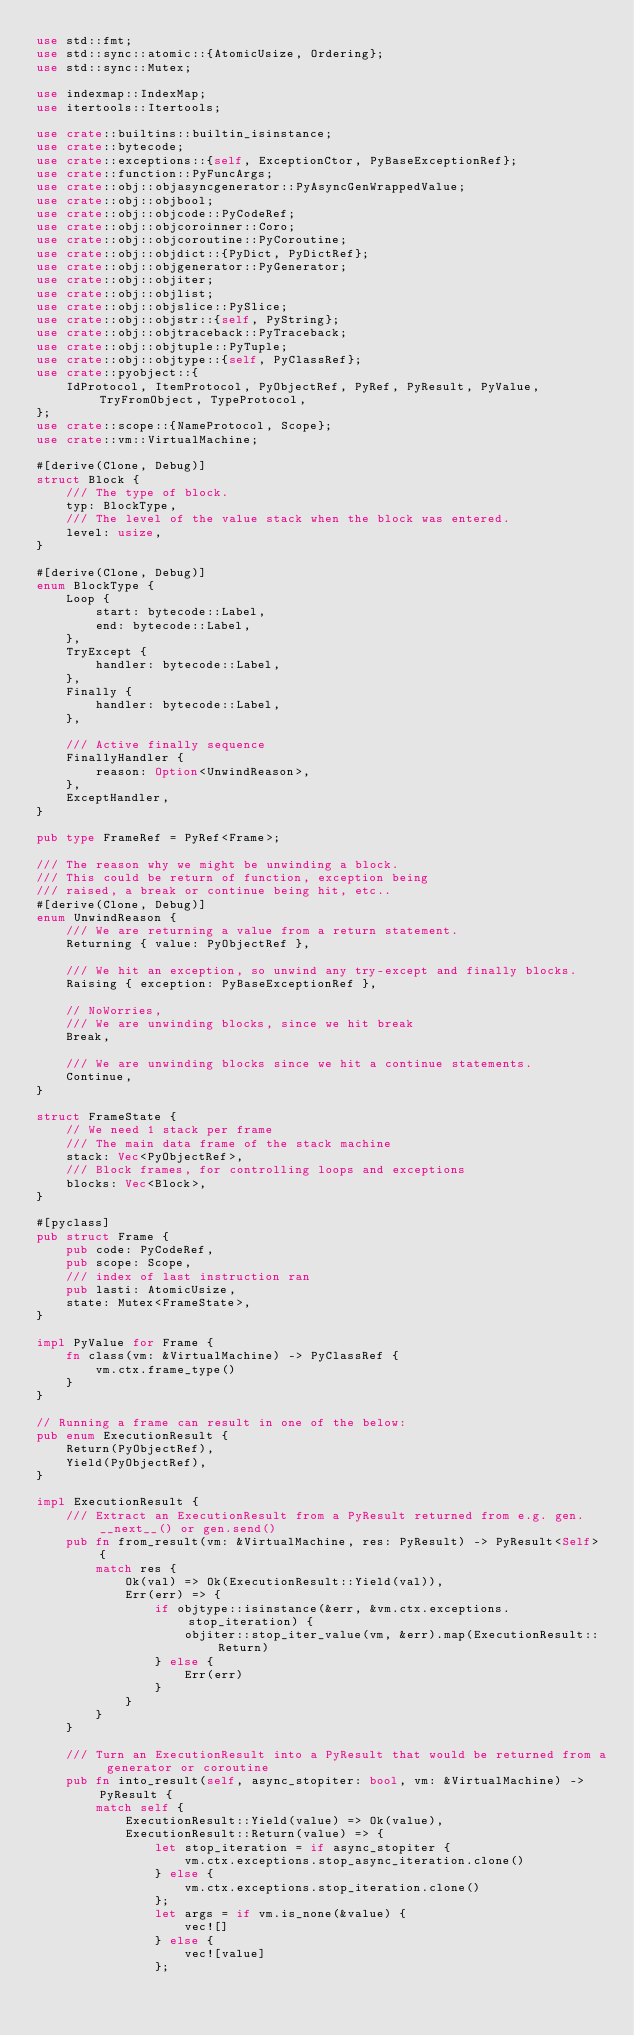<code> <loc_0><loc_0><loc_500><loc_500><_Rust_>use std::fmt;
use std::sync::atomic::{AtomicUsize, Ordering};
use std::sync::Mutex;

use indexmap::IndexMap;
use itertools::Itertools;

use crate::builtins::builtin_isinstance;
use crate::bytecode;
use crate::exceptions::{self, ExceptionCtor, PyBaseExceptionRef};
use crate::function::PyFuncArgs;
use crate::obj::objasyncgenerator::PyAsyncGenWrappedValue;
use crate::obj::objbool;
use crate::obj::objcode::PyCodeRef;
use crate::obj::objcoroinner::Coro;
use crate::obj::objcoroutine::PyCoroutine;
use crate::obj::objdict::{PyDict, PyDictRef};
use crate::obj::objgenerator::PyGenerator;
use crate::obj::objiter;
use crate::obj::objlist;
use crate::obj::objslice::PySlice;
use crate::obj::objstr::{self, PyString};
use crate::obj::objtraceback::PyTraceback;
use crate::obj::objtuple::PyTuple;
use crate::obj::objtype::{self, PyClassRef};
use crate::pyobject::{
    IdProtocol, ItemProtocol, PyObjectRef, PyRef, PyResult, PyValue, TryFromObject, TypeProtocol,
};
use crate::scope::{NameProtocol, Scope};
use crate::vm::VirtualMachine;

#[derive(Clone, Debug)]
struct Block {
    /// The type of block.
    typ: BlockType,
    /// The level of the value stack when the block was entered.
    level: usize,
}

#[derive(Clone, Debug)]
enum BlockType {
    Loop {
        start: bytecode::Label,
        end: bytecode::Label,
    },
    TryExcept {
        handler: bytecode::Label,
    },
    Finally {
        handler: bytecode::Label,
    },

    /// Active finally sequence
    FinallyHandler {
        reason: Option<UnwindReason>,
    },
    ExceptHandler,
}

pub type FrameRef = PyRef<Frame>;

/// The reason why we might be unwinding a block.
/// This could be return of function, exception being
/// raised, a break or continue being hit, etc..
#[derive(Clone, Debug)]
enum UnwindReason {
    /// We are returning a value from a return statement.
    Returning { value: PyObjectRef },

    /// We hit an exception, so unwind any try-except and finally blocks.
    Raising { exception: PyBaseExceptionRef },

    // NoWorries,
    /// We are unwinding blocks, since we hit break
    Break,

    /// We are unwinding blocks since we hit a continue statements.
    Continue,
}

struct FrameState {
    // We need 1 stack per frame
    /// The main data frame of the stack machine
    stack: Vec<PyObjectRef>,
    /// Block frames, for controlling loops and exceptions
    blocks: Vec<Block>,
}

#[pyclass]
pub struct Frame {
    pub code: PyCodeRef,
    pub scope: Scope,
    /// index of last instruction ran
    pub lasti: AtomicUsize,
    state: Mutex<FrameState>,
}

impl PyValue for Frame {
    fn class(vm: &VirtualMachine) -> PyClassRef {
        vm.ctx.frame_type()
    }
}

// Running a frame can result in one of the below:
pub enum ExecutionResult {
    Return(PyObjectRef),
    Yield(PyObjectRef),
}

impl ExecutionResult {
    /// Extract an ExecutionResult from a PyResult returned from e.g. gen.__next__() or gen.send()
    pub fn from_result(vm: &VirtualMachine, res: PyResult) -> PyResult<Self> {
        match res {
            Ok(val) => Ok(ExecutionResult::Yield(val)),
            Err(err) => {
                if objtype::isinstance(&err, &vm.ctx.exceptions.stop_iteration) {
                    objiter::stop_iter_value(vm, &err).map(ExecutionResult::Return)
                } else {
                    Err(err)
                }
            }
        }
    }

    /// Turn an ExecutionResult into a PyResult that would be returned from a generator or coroutine
    pub fn into_result(self, async_stopiter: bool, vm: &VirtualMachine) -> PyResult {
        match self {
            ExecutionResult::Yield(value) => Ok(value),
            ExecutionResult::Return(value) => {
                let stop_iteration = if async_stopiter {
                    vm.ctx.exceptions.stop_async_iteration.clone()
                } else {
                    vm.ctx.exceptions.stop_iteration.clone()
                };
                let args = if vm.is_none(&value) {
                    vec![]
                } else {
                    vec![value]
                };</code> 